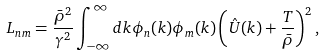Convert formula to latex. <formula><loc_0><loc_0><loc_500><loc_500>L _ { n m } = \frac { \bar { \rho } ^ { 2 } } { \gamma ^ { 2 } } \int _ { - \infty } ^ { \infty } d k \phi _ { n } ( k ) \phi _ { m } ( k ) \left ( \hat { U } ( k ) + \frac { T } { \bar { \rho } } \right ) ^ { 2 } ,</formula> 